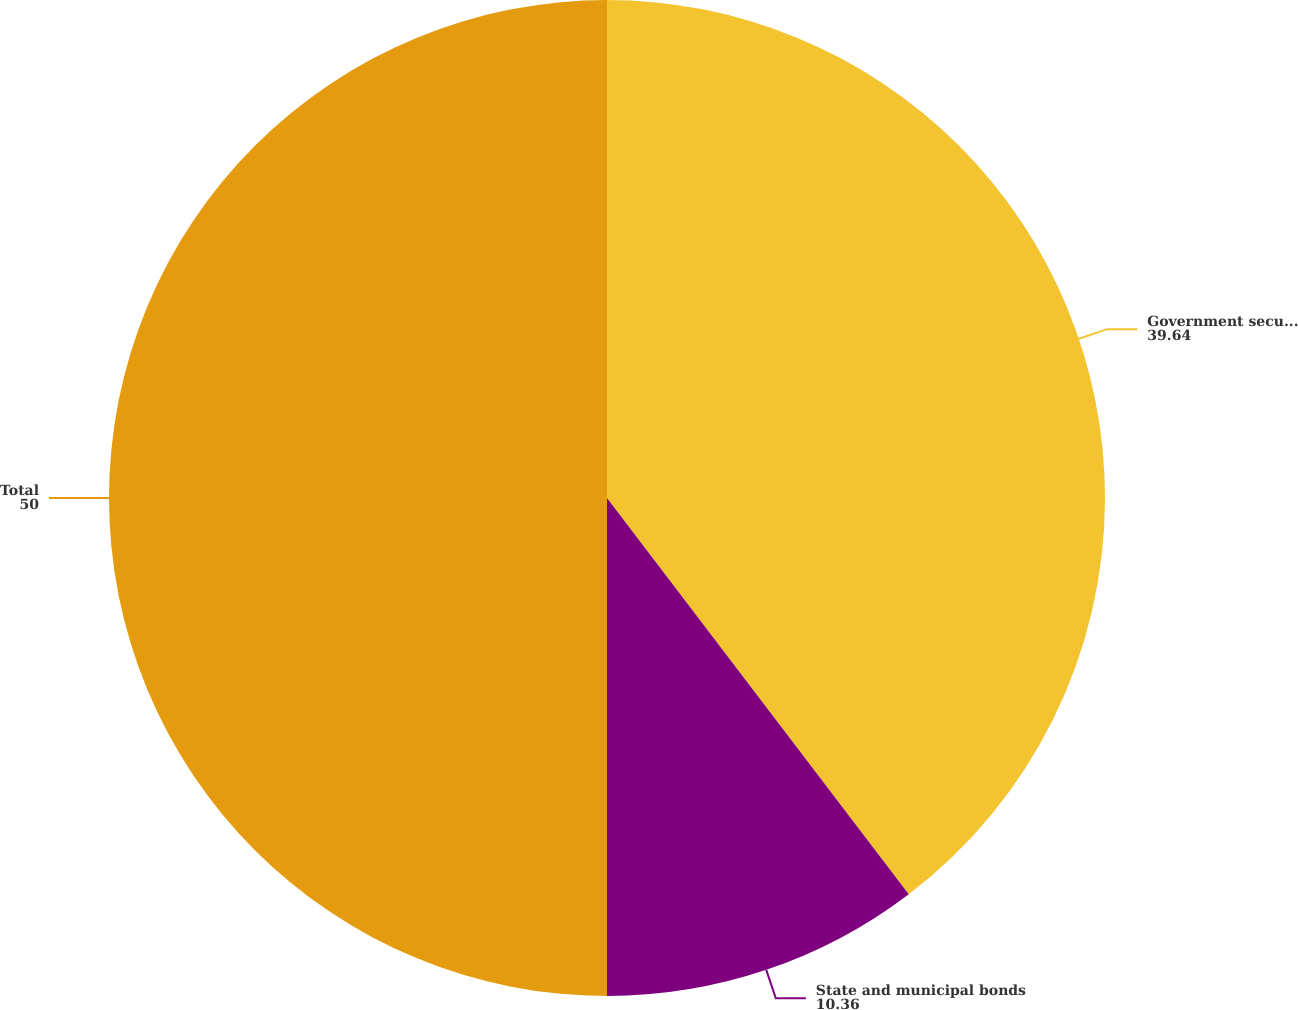Convert chart. <chart><loc_0><loc_0><loc_500><loc_500><pie_chart><fcel>Government securities<fcel>State and municipal bonds<fcel>Total<nl><fcel>39.64%<fcel>10.36%<fcel>50.0%<nl></chart> 